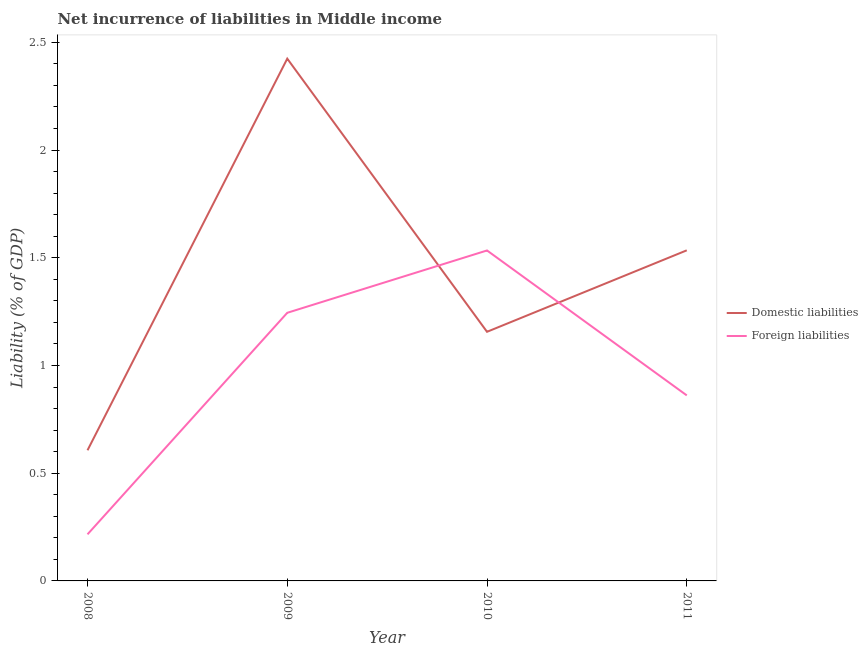How many different coloured lines are there?
Keep it short and to the point. 2. Does the line corresponding to incurrence of domestic liabilities intersect with the line corresponding to incurrence of foreign liabilities?
Your answer should be compact. Yes. Is the number of lines equal to the number of legend labels?
Offer a terse response. Yes. What is the incurrence of foreign liabilities in 2009?
Give a very brief answer. 1.24. Across all years, what is the maximum incurrence of domestic liabilities?
Offer a very short reply. 2.42. Across all years, what is the minimum incurrence of foreign liabilities?
Give a very brief answer. 0.22. In which year was the incurrence of foreign liabilities maximum?
Ensure brevity in your answer.  2010. In which year was the incurrence of foreign liabilities minimum?
Provide a short and direct response. 2008. What is the total incurrence of domestic liabilities in the graph?
Keep it short and to the point. 5.72. What is the difference between the incurrence of domestic liabilities in 2008 and that in 2011?
Provide a short and direct response. -0.93. What is the difference between the incurrence of domestic liabilities in 2011 and the incurrence of foreign liabilities in 2009?
Your answer should be very brief. 0.29. What is the average incurrence of foreign liabilities per year?
Keep it short and to the point. 0.96. In the year 2009, what is the difference between the incurrence of foreign liabilities and incurrence of domestic liabilities?
Make the answer very short. -1.18. In how many years, is the incurrence of foreign liabilities greater than 0.1 %?
Your response must be concise. 4. What is the ratio of the incurrence of domestic liabilities in 2009 to that in 2010?
Make the answer very short. 2.1. What is the difference between the highest and the second highest incurrence of foreign liabilities?
Give a very brief answer. 0.29. What is the difference between the highest and the lowest incurrence of domestic liabilities?
Provide a short and direct response. 1.82. Is the incurrence of foreign liabilities strictly greater than the incurrence of domestic liabilities over the years?
Provide a short and direct response. No. Is the incurrence of domestic liabilities strictly less than the incurrence of foreign liabilities over the years?
Offer a very short reply. No. How many lines are there?
Your answer should be compact. 2. What is the difference between two consecutive major ticks on the Y-axis?
Your answer should be compact. 0.5. Does the graph contain any zero values?
Keep it short and to the point. No. Does the graph contain grids?
Provide a succinct answer. No. How many legend labels are there?
Give a very brief answer. 2. How are the legend labels stacked?
Give a very brief answer. Vertical. What is the title of the graph?
Your answer should be compact. Net incurrence of liabilities in Middle income. Does "Grants" appear as one of the legend labels in the graph?
Offer a terse response. No. What is the label or title of the Y-axis?
Give a very brief answer. Liability (% of GDP). What is the Liability (% of GDP) in Domestic liabilities in 2008?
Give a very brief answer. 0.61. What is the Liability (% of GDP) in Foreign liabilities in 2008?
Ensure brevity in your answer.  0.22. What is the Liability (% of GDP) in Domestic liabilities in 2009?
Provide a short and direct response. 2.42. What is the Liability (% of GDP) in Foreign liabilities in 2009?
Provide a succinct answer. 1.24. What is the Liability (% of GDP) in Domestic liabilities in 2010?
Offer a very short reply. 1.16. What is the Liability (% of GDP) of Foreign liabilities in 2010?
Your answer should be very brief. 1.53. What is the Liability (% of GDP) in Domestic liabilities in 2011?
Offer a very short reply. 1.53. What is the Liability (% of GDP) in Foreign liabilities in 2011?
Provide a short and direct response. 0.86. Across all years, what is the maximum Liability (% of GDP) in Domestic liabilities?
Provide a succinct answer. 2.42. Across all years, what is the maximum Liability (% of GDP) of Foreign liabilities?
Provide a short and direct response. 1.53. Across all years, what is the minimum Liability (% of GDP) in Domestic liabilities?
Your response must be concise. 0.61. Across all years, what is the minimum Liability (% of GDP) in Foreign liabilities?
Your answer should be compact. 0.22. What is the total Liability (% of GDP) in Domestic liabilities in the graph?
Offer a very short reply. 5.72. What is the total Liability (% of GDP) in Foreign liabilities in the graph?
Provide a succinct answer. 3.86. What is the difference between the Liability (% of GDP) of Domestic liabilities in 2008 and that in 2009?
Offer a very short reply. -1.82. What is the difference between the Liability (% of GDP) of Foreign liabilities in 2008 and that in 2009?
Keep it short and to the point. -1.03. What is the difference between the Liability (% of GDP) of Domestic liabilities in 2008 and that in 2010?
Offer a very short reply. -0.55. What is the difference between the Liability (% of GDP) in Foreign liabilities in 2008 and that in 2010?
Keep it short and to the point. -1.32. What is the difference between the Liability (% of GDP) in Domestic liabilities in 2008 and that in 2011?
Your response must be concise. -0.93. What is the difference between the Liability (% of GDP) of Foreign liabilities in 2008 and that in 2011?
Keep it short and to the point. -0.65. What is the difference between the Liability (% of GDP) of Domestic liabilities in 2009 and that in 2010?
Provide a succinct answer. 1.27. What is the difference between the Liability (% of GDP) in Foreign liabilities in 2009 and that in 2010?
Give a very brief answer. -0.29. What is the difference between the Liability (% of GDP) in Domestic liabilities in 2009 and that in 2011?
Your answer should be very brief. 0.89. What is the difference between the Liability (% of GDP) of Foreign liabilities in 2009 and that in 2011?
Provide a succinct answer. 0.38. What is the difference between the Liability (% of GDP) in Domestic liabilities in 2010 and that in 2011?
Your response must be concise. -0.38. What is the difference between the Liability (% of GDP) of Foreign liabilities in 2010 and that in 2011?
Your answer should be very brief. 0.67. What is the difference between the Liability (% of GDP) in Domestic liabilities in 2008 and the Liability (% of GDP) in Foreign liabilities in 2009?
Make the answer very short. -0.64. What is the difference between the Liability (% of GDP) in Domestic liabilities in 2008 and the Liability (% of GDP) in Foreign liabilities in 2010?
Your response must be concise. -0.93. What is the difference between the Liability (% of GDP) in Domestic liabilities in 2008 and the Liability (% of GDP) in Foreign liabilities in 2011?
Your answer should be very brief. -0.25. What is the difference between the Liability (% of GDP) of Domestic liabilities in 2009 and the Liability (% of GDP) of Foreign liabilities in 2010?
Provide a succinct answer. 0.89. What is the difference between the Liability (% of GDP) in Domestic liabilities in 2009 and the Liability (% of GDP) in Foreign liabilities in 2011?
Keep it short and to the point. 1.56. What is the difference between the Liability (% of GDP) of Domestic liabilities in 2010 and the Liability (% of GDP) of Foreign liabilities in 2011?
Provide a succinct answer. 0.3. What is the average Liability (% of GDP) in Domestic liabilities per year?
Your answer should be compact. 1.43. What is the average Liability (% of GDP) in Foreign liabilities per year?
Ensure brevity in your answer.  0.96. In the year 2008, what is the difference between the Liability (% of GDP) in Domestic liabilities and Liability (% of GDP) in Foreign liabilities?
Your answer should be very brief. 0.39. In the year 2009, what is the difference between the Liability (% of GDP) of Domestic liabilities and Liability (% of GDP) of Foreign liabilities?
Your response must be concise. 1.18. In the year 2010, what is the difference between the Liability (% of GDP) of Domestic liabilities and Liability (% of GDP) of Foreign liabilities?
Provide a succinct answer. -0.38. In the year 2011, what is the difference between the Liability (% of GDP) in Domestic liabilities and Liability (% of GDP) in Foreign liabilities?
Your answer should be very brief. 0.67. What is the ratio of the Liability (% of GDP) in Domestic liabilities in 2008 to that in 2009?
Your answer should be very brief. 0.25. What is the ratio of the Liability (% of GDP) in Foreign liabilities in 2008 to that in 2009?
Ensure brevity in your answer.  0.17. What is the ratio of the Liability (% of GDP) of Domestic liabilities in 2008 to that in 2010?
Your answer should be compact. 0.52. What is the ratio of the Liability (% of GDP) in Foreign liabilities in 2008 to that in 2010?
Your response must be concise. 0.14. What is the ratio of the Liability (% of GDP) of Domestic liabilities in 2008 to that in 2011?
Your response must be concise. 0.4. What is the ratio of the Liability (% of GDP) of Foreign liabilities in 2008 to that in 2011?
Provide a short and direct response. 0.25. What is the ratio of the Liability (% of GDP) of Domestic liabilities in 2009 to that in 2010?
Offer a very short reply. 2.1. What is the ratio of the Liability (% of GDP) of Foreign liabilities in 2009 to that in 2010?
Give a very brief answer. 0.81. What is the ratio of the Liability (% of GDP) in Domestic liabilities in 2009 to that in 2011?
Keep it short and to the point. 1.58. What is the ratio of the Liability (% of GDP) of Foreign liabilities in 2009 to that in 2011?
Your answer should be very brief. 1.45. What is the ratio of the Liability (% of GDP) of Domestic liabilities in 2010 to that in 2011?
Offer a very short reply. 0.75. What is the ratio of the Liability (% of GDP) in Foreign liabilities in 2010 to that in 2011?
Make the answer very short. 1.78. What is the difference between the highest and the second highest Liability (% of GDP) in Domestic liabilities?
Keep it short and to the point. 0.89. What is the difference between the highest and the second highest Liability (% of GDP) of Foreign liabilities?
Provide a short and direct response. 0.29. What is the difference between the highest and the lowest Liability (% of GDP) in Domestic liabilities?
Keep it short and to the point. 1.82. What is the difference between the highest and the lowest Liability (% of GDP) in Foreign liabilities?
Offer a very short reply. 1.32. 